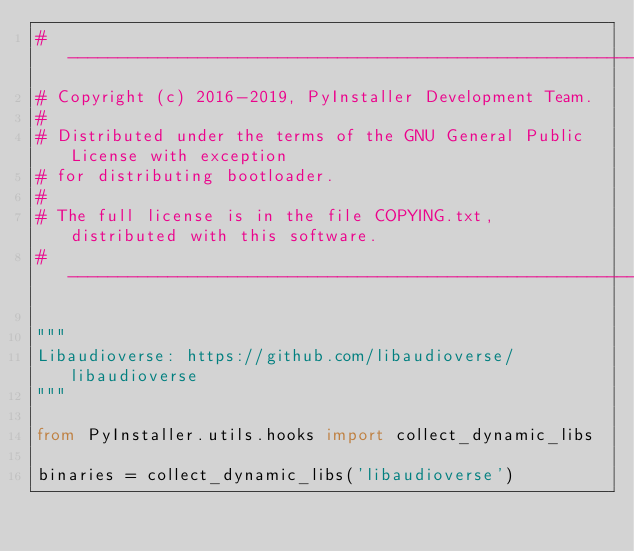<code> <loc_0><loc_0><loc_500><loc_500><_Python_>#-----------------------------------------------------------------------------
# Copyright (c) 2016-2019, PyInstaller Development Team.
#
# Distributed under the terms of the GNU General Public License with exception
# for distributing bootloader.
#
# The full license is in the file COPYING.txt, distributed with this software.
#-----------------------------------------------------------------------------

"""
Libaudioverse: https://github.com/libaudioverse/libaudioverse
"""

from PyInstaller.utils.hooks import collect_dynamic_libs

binaries = collect_dynamic_libs('libaudioverse')
</code> 